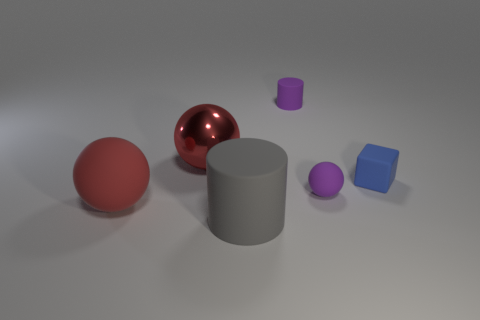Add 1 big green rubber balls. How many objects exist? 7 Subtract all cylinders. How many objects are left? 4 Add 1 small purple cylinders. How many small purple cylinders are left? 2 Add 6 red things. How many red things exist? 8 Subtract 1 purple cylinders. How many objects are left? 5 Subtract all tiny cubes. Subtract all tiny gray matte balls. How many objects are left? 5 